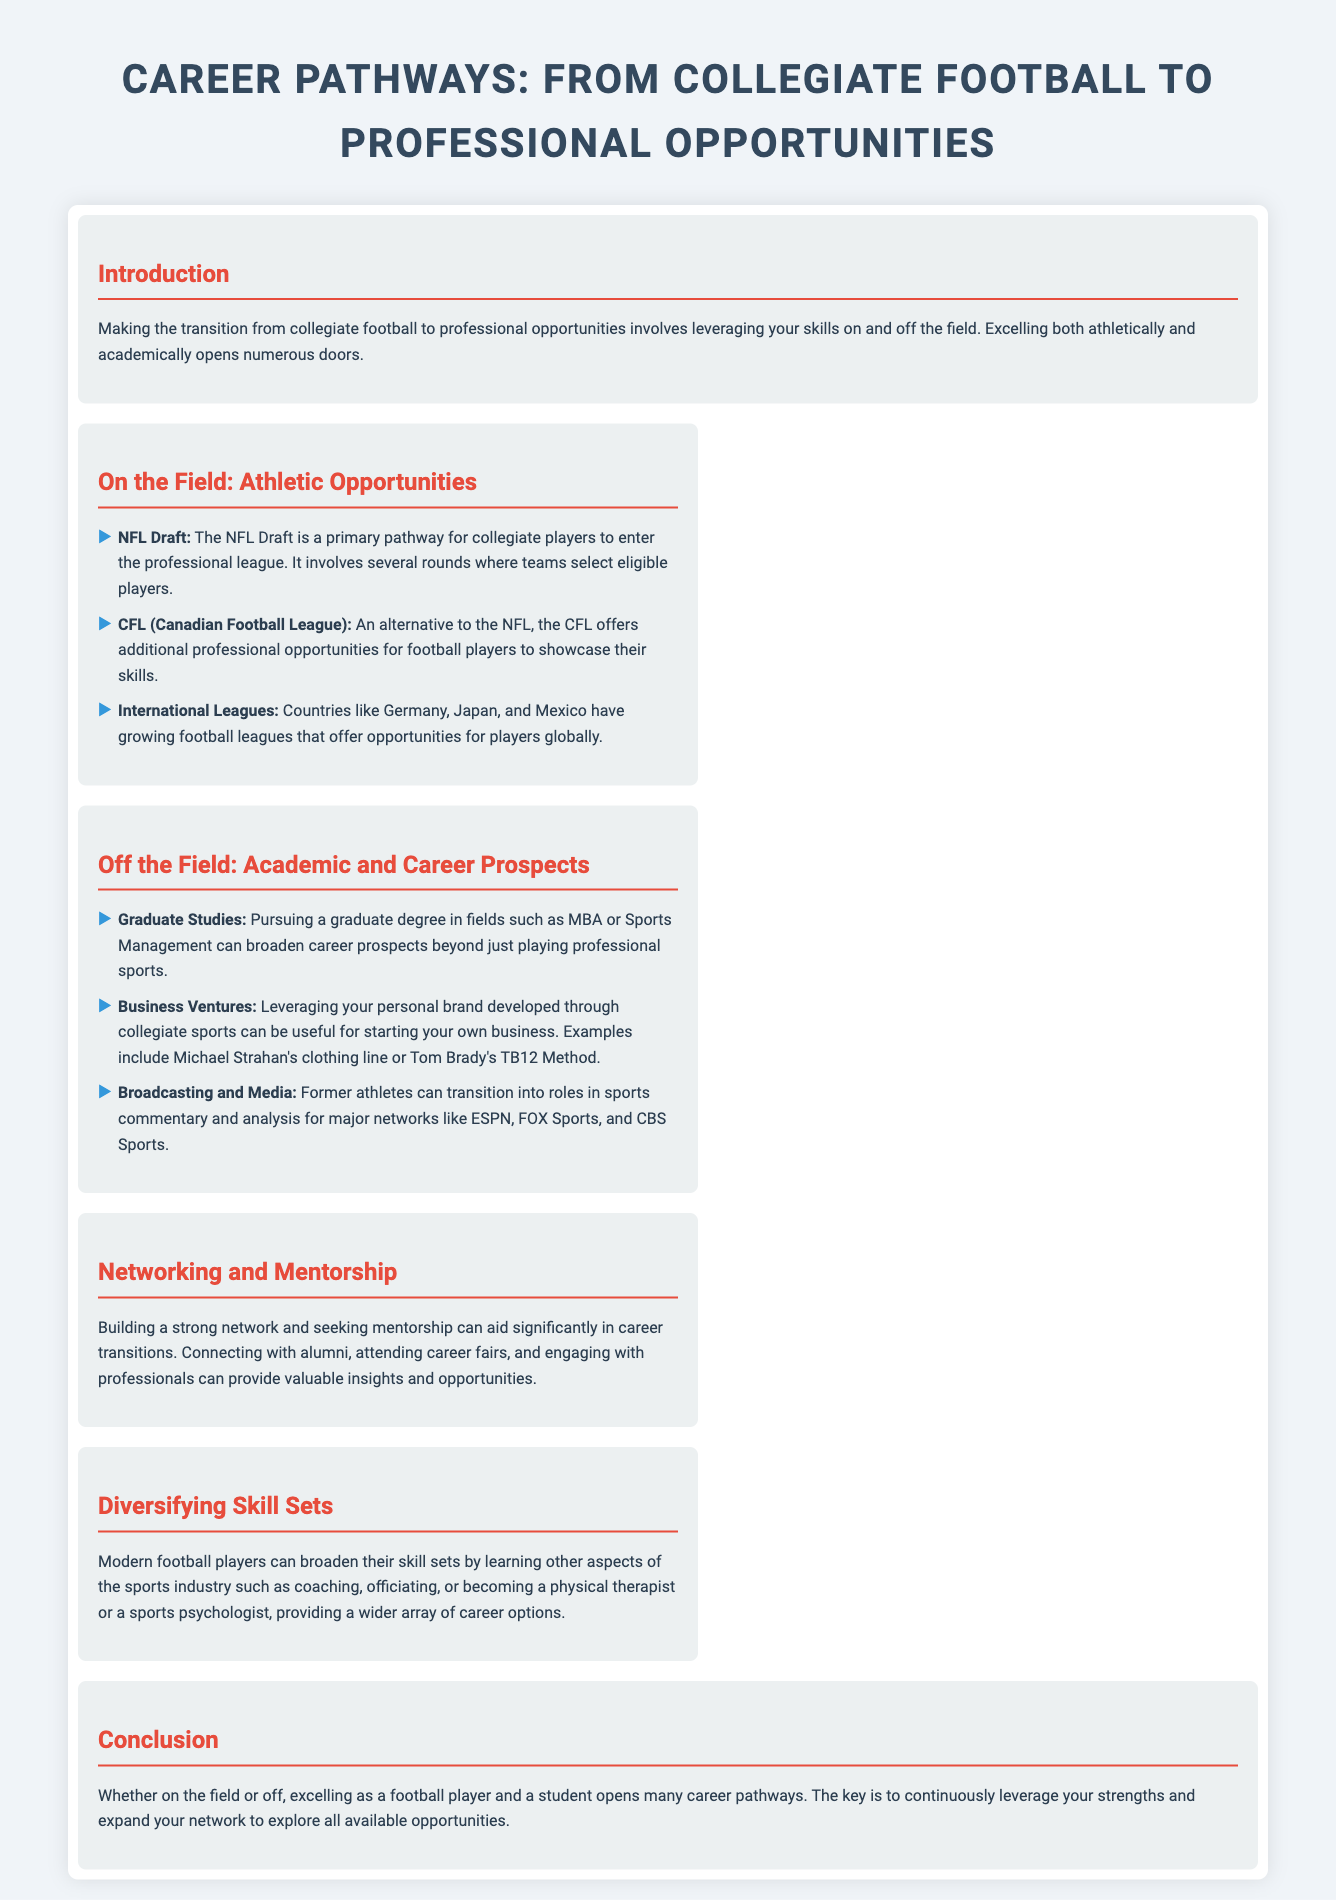What is the main theme of the infographic? The main theme of the infographic discusses the transition from collegiate football to various professional opportunities.
Answer: Career Pathways: From Collegiate Football to Professional Opportunities Which league is a primary pathway for collegiate players? The infographic specifically mentions the NFL Draft as a primary pathway for collegiate players.
Answer: NFL Draft What is one alternative professional league mentioned? The infographic refers to the CFL as an alternative to the NFL for professional opportunities.
Answer: CFL Name a type of graduate degree that can broaden career prospects. The document lists MBA or Sports Management as fields for graduate studies to broaden career prospects.
Answer: MBA What is a way to leverage a personal brand developed through collegiate sports? The infographic provides examples of using a personal brand to start a business, such as clothing lines.
Answer: Starting your own business What can former athletes transition into regarding media? The infographic states that former athletes can move into sports commentary and analysis roles.
Answer: Broadcasting and Media What is a suggested method to aid career transitions? Building a strong network and seeking mentorship is suggested in the infographic as a method to aid career transitions.
Answer: Networking and Mentorship What aspect of the sports industry can players learn to diversify their skill sets? The infographic suggests learning coaching, officiating, or sports psychology as skills players can diversify into.
Answer: Coaching What is the overall key to exploring available opportunities? The infographic concludes that continuously leveraging strengths and expanding networks is crucial for exploring opportunities.
Answer: Leverage your strengths and expand your network 